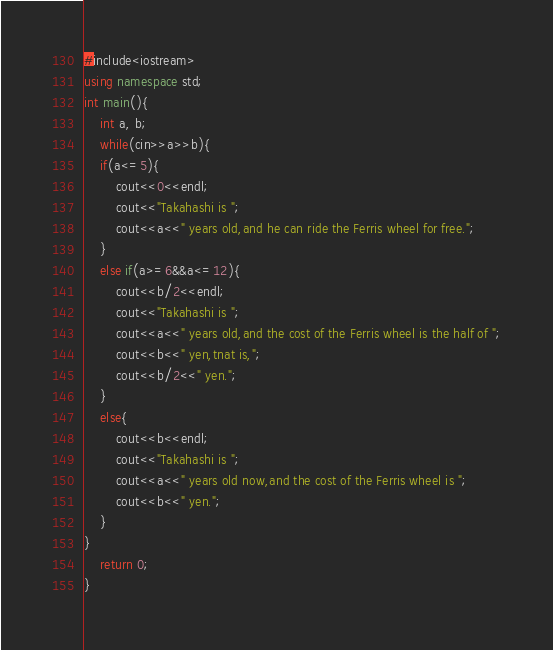Convert code to text. <code><loc_0><loc_0><loc_500><loc_500><_C#_>#include<iostream>
using namespace std;
int main(){
	int a, b;
	while(cin>>a>>b){
	if(a<=5){
		cout<<0<<endl;
		cout<<"Takahashi is ";
		cout<<a<<" years old,and he can ride the Ferris wheel for free.";	
	}
	else if(a>=6&&a<=12){
		cout<<b/2<<endl;
		cout<<"Takahashi is ";
		cout<<a<<" years old,and the cost of the Ferris wheel is the half of ";
		cout<<b<<" yen,tnat is,";
		cout<<b/2<<" yen.";
	}	
	else{
		cout<<b<<endl;
		cout<<"Takahashi is ";
		cout<<a<<" years old now,and the cost of the Ferris wheel is ";
		cout<<b<<" yen.";
	}
}
	return 0;
} </code> 